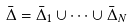<formula> <loc_0><loc_0><loc_500><loc_500>\bar { \Delta } = \bar { \Delta } _ { 1 } \cup \cdots \cup \bar { \Delta } _ { N }</formula> 